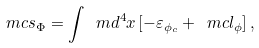Convert formula to latex. <formula><loc_0><loc_0><loc_500><loc_500>\ m c s _ { \Phi } = \int \ m d ^ { 4 } x \left [ - \varepsilon _ { \phi _ { c } } + \ m c l _ { \phi } \right ] ,</formula> 